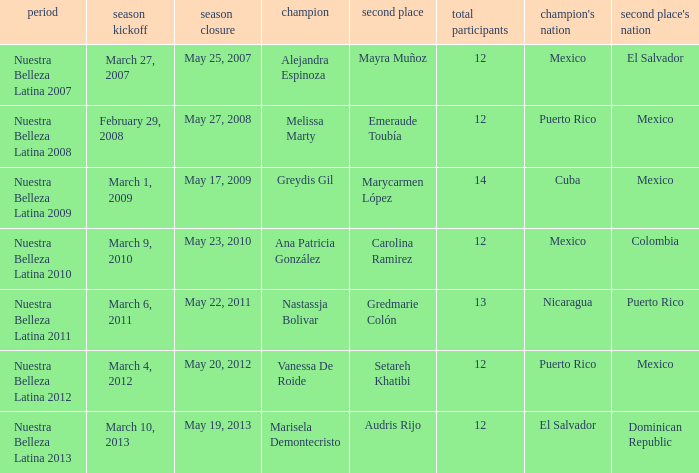What season had more than 12 contestants in which greydis gil won? Nuestra Belleza Latina 2009. Parse the full table. {'header': ['period', 'season kickoff', 'season closure', 'champion', 'second place', 'total participants', "champion's nation", "second place's nation"], 'rows': [['Nuestra Belleza Latina 2007', 'March 27, 2007', 'May 25, 2007', 'Alejandra Espinoza', 'Mayra Muñoz', '12', 'Mexico', 'El Salvador'], ['Nuestra Belleza Latina 2008', 'February 29, 2008', 'May 27, 2008', 'Melissa Marty', 'Emeraude Toubía', '12', 'Puerto Rico', 'Mexico'], ['Nuestra Belleza Latina 2009', 'March 1, 2009', 'May 17, 2009', 'Greydis Gil', 'Marycarmen López', '14', 'Cuba', 'Mexico'], ['Nuestra Belleza Latina 2010', 'March 9, 2010', 'May 23, 2010', 'Ana Patricia González', 'Carolina Ramirez', '12', 'Mexico', 'Colombia'], ['Nuestra Belleza Latina 2011', 'March 6, 2011', 'May 22, 2011', 'Nastassja Bolivar', 'Gredmarie Colón', '13', 'Nicaragua', 'Puerto Rico'], ['Nuestra Belleza Latina 2012', 'March 4, 2012', 'May 20, 2012', 'Vanessa De Roide', 'Setareh Khatibi', '12', 'Puerto Rico', 'Mexico'], ['Nuestra Belleza Latina 2013', 'March 10, 2013', 'May 19, 2013', 'Marisela Demontecristo', 'Audris Rijo', '12', 'El Salvador', 'Dominican Republic']]} 